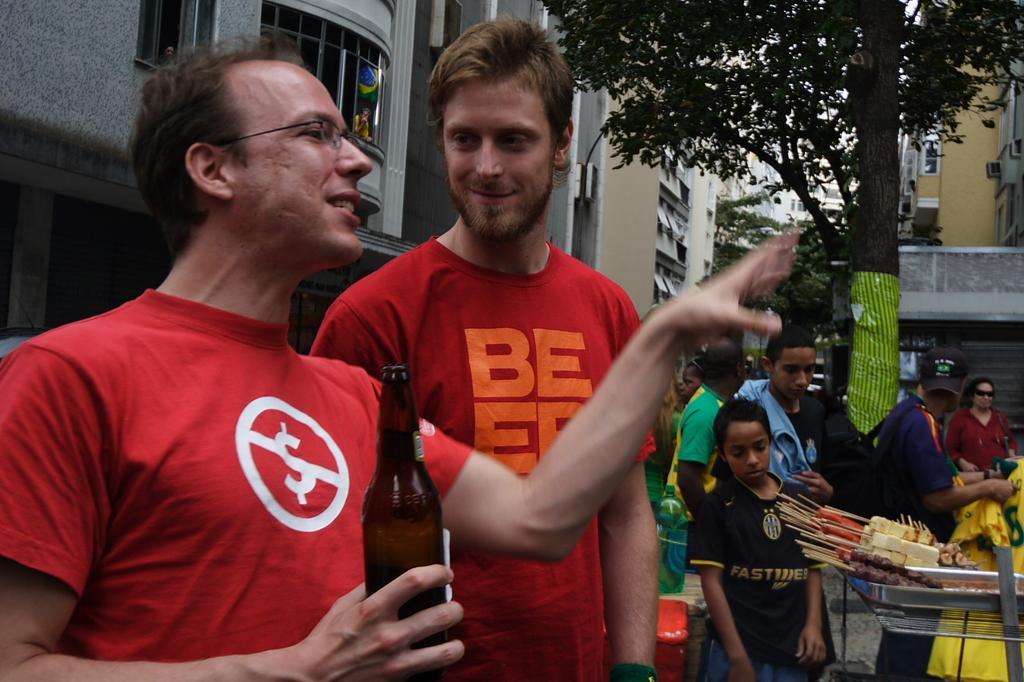Please provide a concise description of this image. In this picture we can see a man in the red t shirt is holding a bottle and behind the man there are some people standing and some food items on a tray. Behind the people there are trees and buildings. 